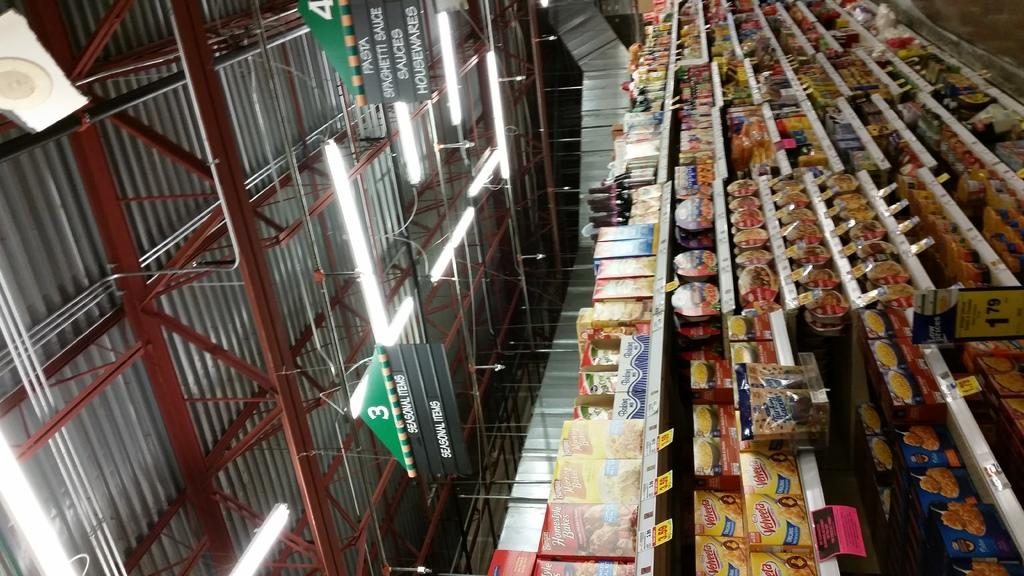<image>
Present a compact description of the photo's key features. A aisle in a supermarket that has macaroni and cheese for $1.79. 